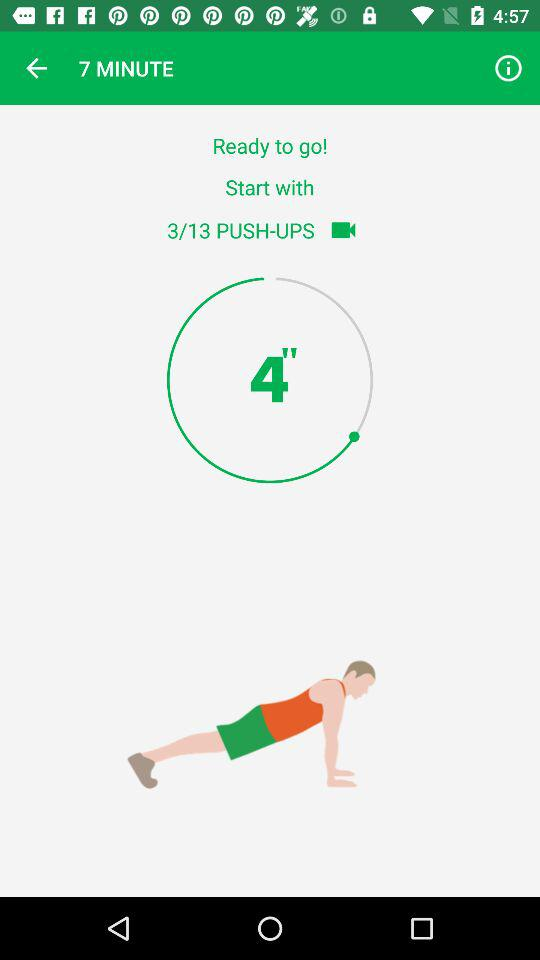How many more push-ups do I have to do?
Answer the question using a single word or phrase. 10 